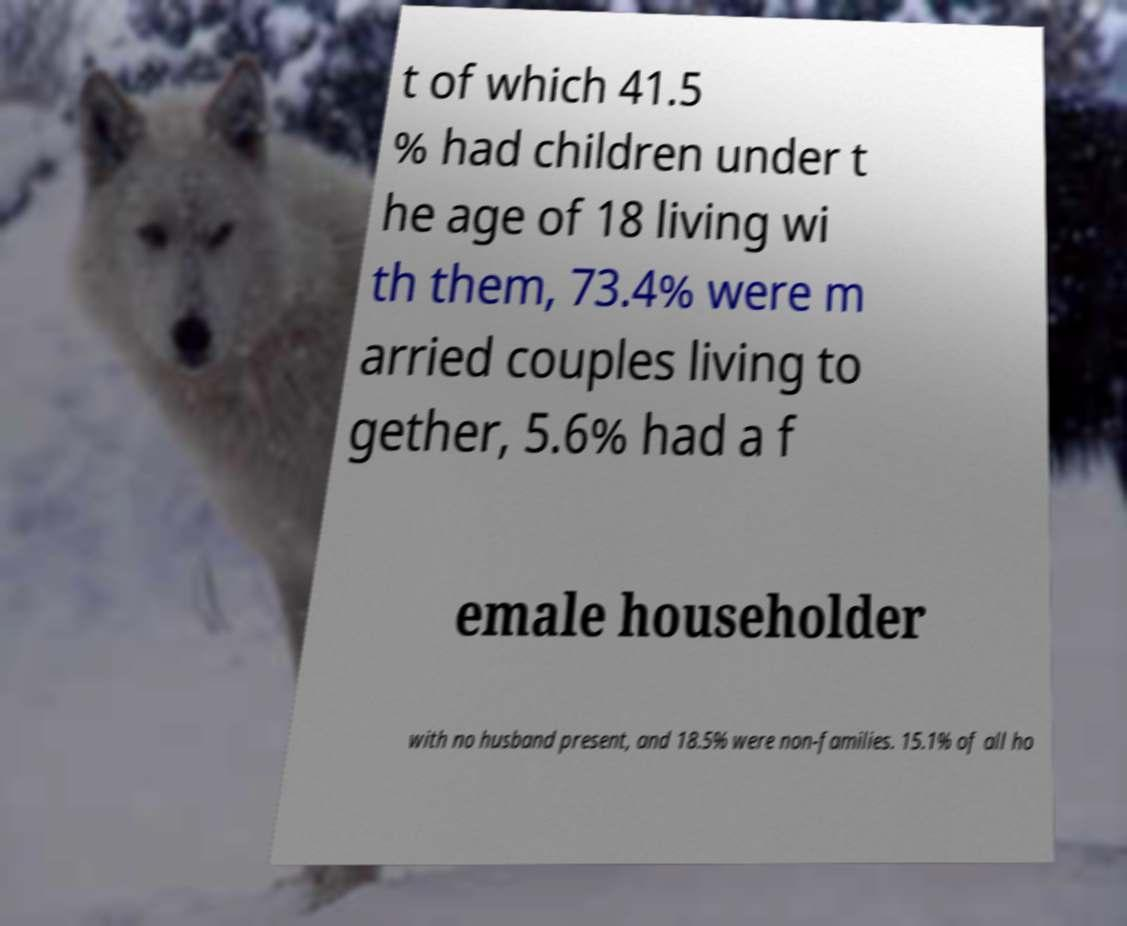There's text embedded in this image that I need extracted. Can you transcribe it verbatim? t of which 41.5 % had children under t he age of 18 living wi th them, 73.4% were m arried couples living to gether, 5.6% had a f emale householder with no husband present, and 18.5% were non-families. 15.1% of all ho 